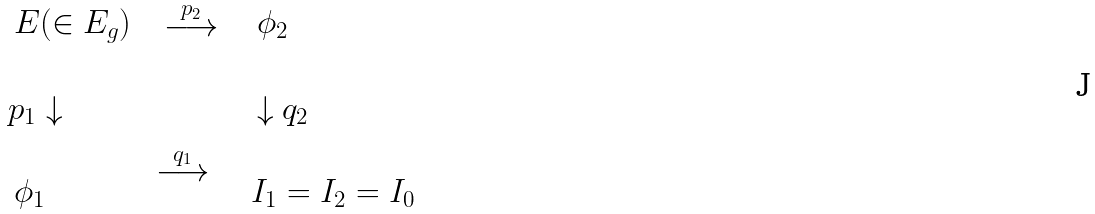Convert formula to latex. <formula><loc_0><loc_0><loc_500><loc_500>\begin{array} { l l l } \begin{array} { l } \\ \, E ( \in E _ { g } ) \end{array} & \begin{array} { l } \\ \stackrel { p _ { 2 } } { \longrightarrow } \end{array} & \begin{array} { l } \, \\ \, \phi _ { 2 } \end{array} \\ \begin{array} { l } \, \\ p _ { 1 } \downarrow \end{array} & & \begin{array} { l } \, \\ \, \downarrow q _ { 2 } \end{array} \\ \begin{array} { l } \, \\ \, \phi _ { 1 } \end{array} & \stackrel { q _ { 1 } } { \longrightarrow } & \begin{array} { l } \\ I _ { 1 } = I _ { 2 } = I _ { 0 } \end{array} \end{array}</formula> 